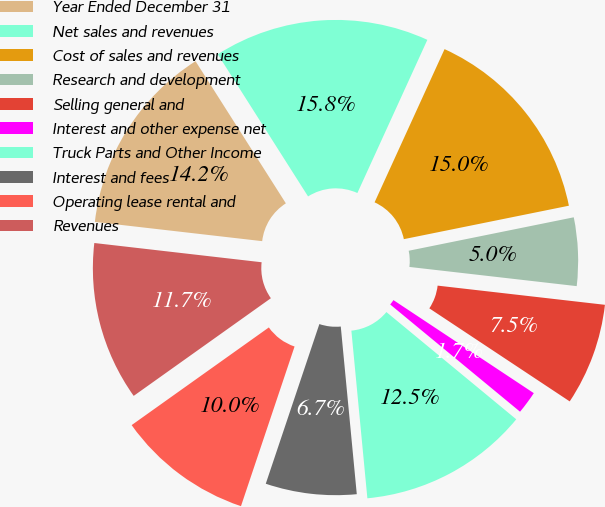Convert chart. <chart><loc_0><loc_0><loc_500><loc_500><pie_chart><fcel>Year Ended December 31<fcel>Net sales and revenues<fcel>Cost of sales and revenues<fcel>Research and development<fcel>Selling general and<fcel>Interest and other expense net<fcel>Truck Parts and Other Income<fcel>Interest and fees<fcel>Operating lease rental and<fcel>Revenues<nl><fcel>14.17%<fcel>15.83%<fcel>15.0%<fcel>5.0%<fcel>7.5%<fcel>1.67%<fcel>12.5%<fcel>6.67%<fcel>10.0%<fcel>11.67%<nl></chart> 